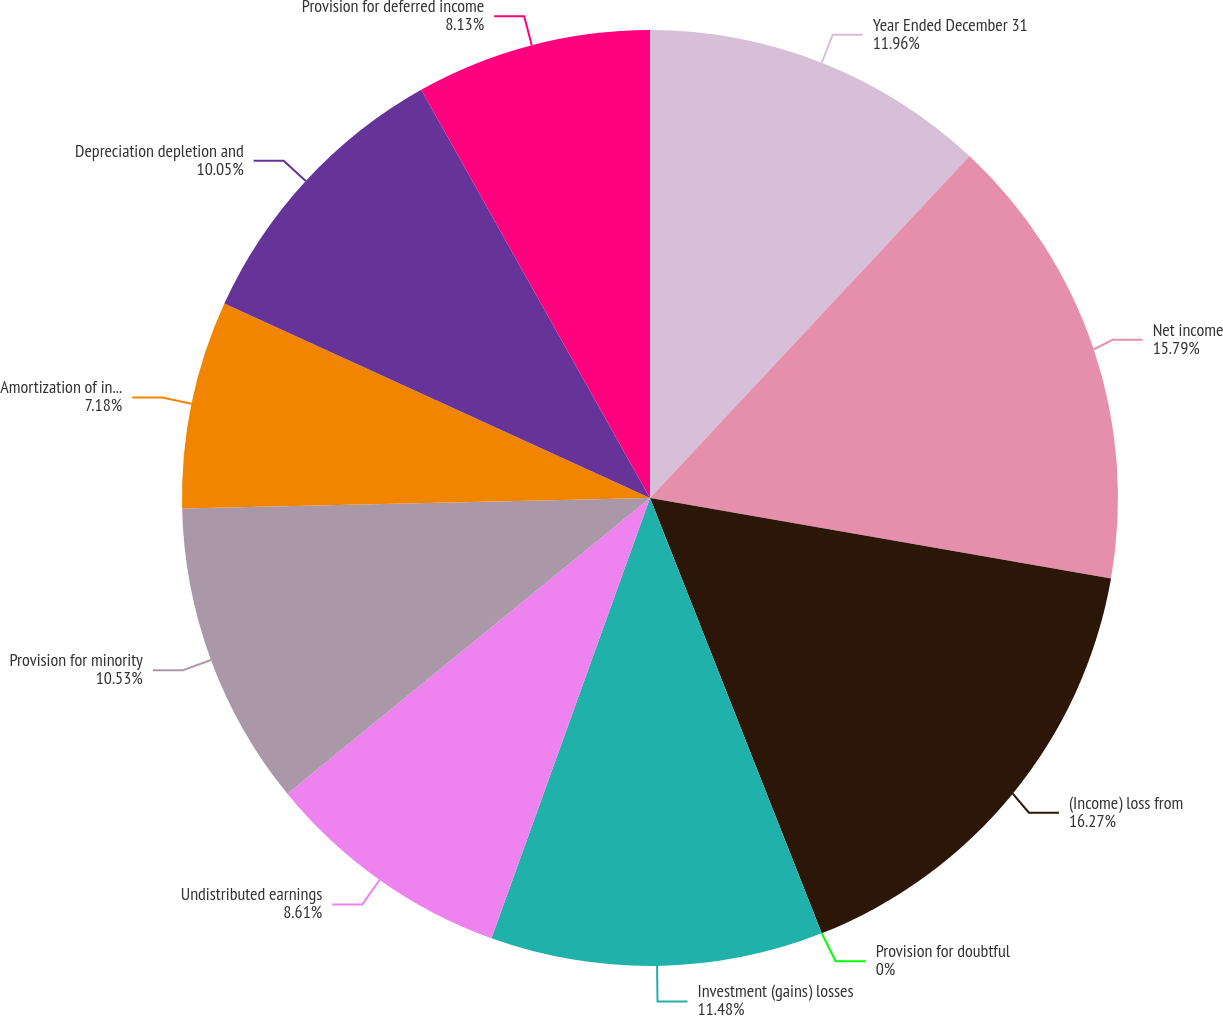<chart> <loc_0><loc_0><loc_500><loc_500><pie_chart><fcel>Year Ended December 31<fcel>Net income<fcel>(Income) loss from<fcel>Provision for doubtful<fcel>Investment (gains) losses<fcel>Undistributed earnings<fcel>Provision for minority<fcel>Amortization of investments<fcel>Depreciation depletion and<fcel>Provision for deferred income<nl><fcel>11.96%<fcel>15.79%<fcel>16.27%<fcel>0.0%<fcel>11.48%<fcel>8.61%<fcel>10.53%<fcel>7.18%<fcel>10.05%<fcel>8.13%<nl></chart> 